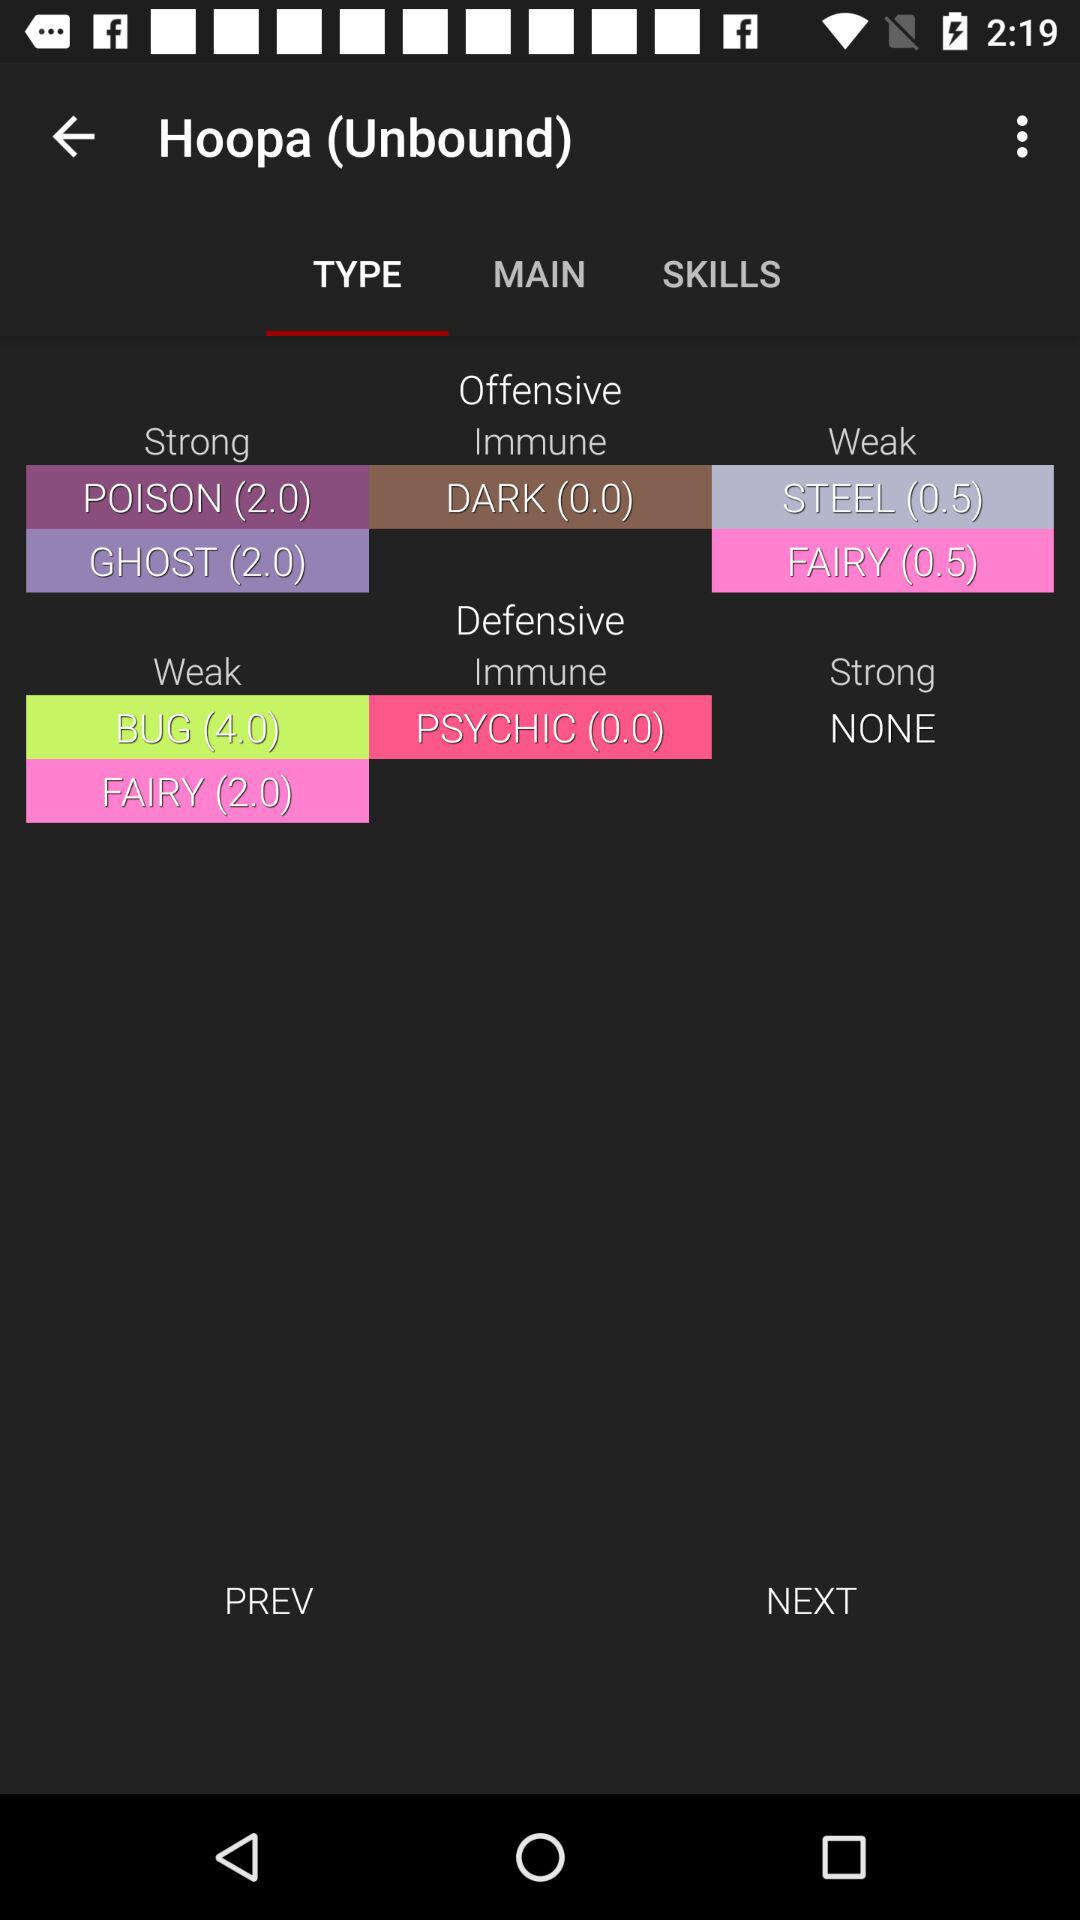Which tab is selected? The selected tab is "TYPE". 